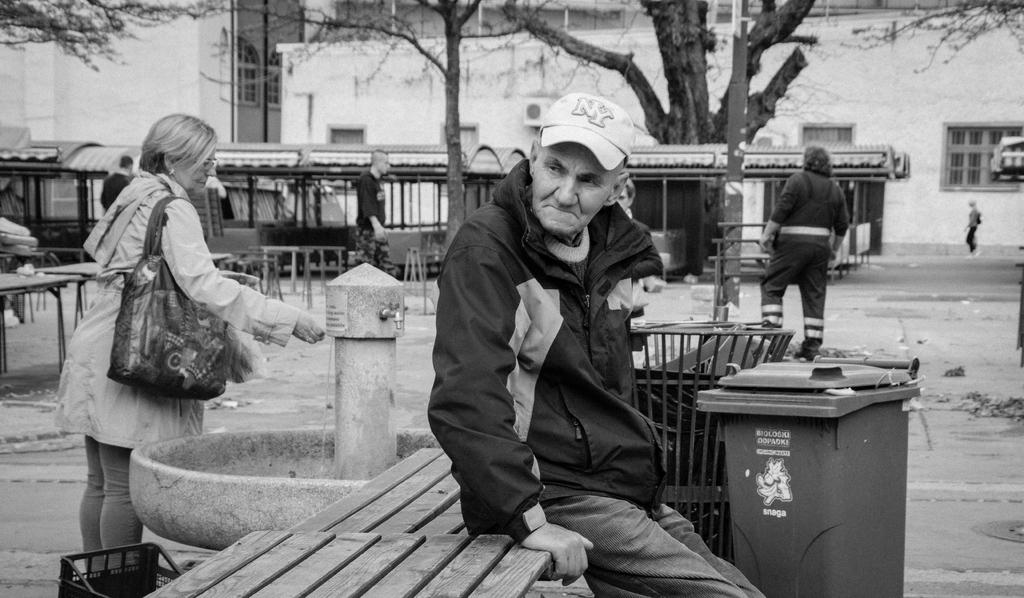<image>
Create a compact narrative representing the image presented. Man sitting next to a garbage can that says "Snaga" on it. 